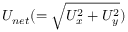Convert formula to latex. <formula><loc_0><loc_0><loc_500><loc_500>U _ { n e t } ( = \sqrt { U _ { x } ^ { 2 } + U _ { y } ^ { 2 } } )</formula> 